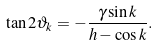<formula> <loc_0><loc_0><loc_500><loc_500>\tan 2 \vartheta _ { k } = - \frac { \gamma \sin k } { h - \cos k } .</formula> 